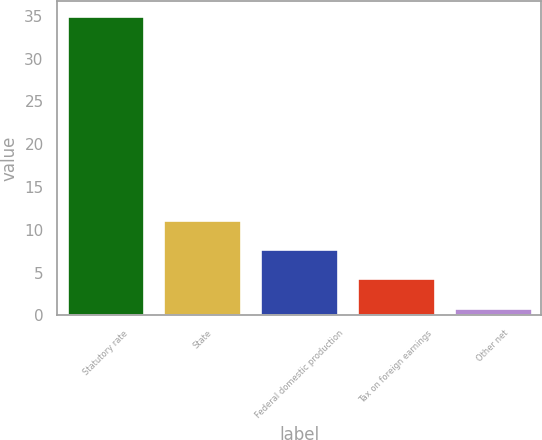<chart> <loc_0><loc_0><loc_500><loc_500><bar_chart><fcel>Statutory rate<fcel>State<fcel>Federal domestic production<fcel>Tax on foreign earnings<fcel>Other net<nl><fcel>35<fcel>11.13<fcel>7.72<fcel>4.31<fcel>0.9<nl></chart> 